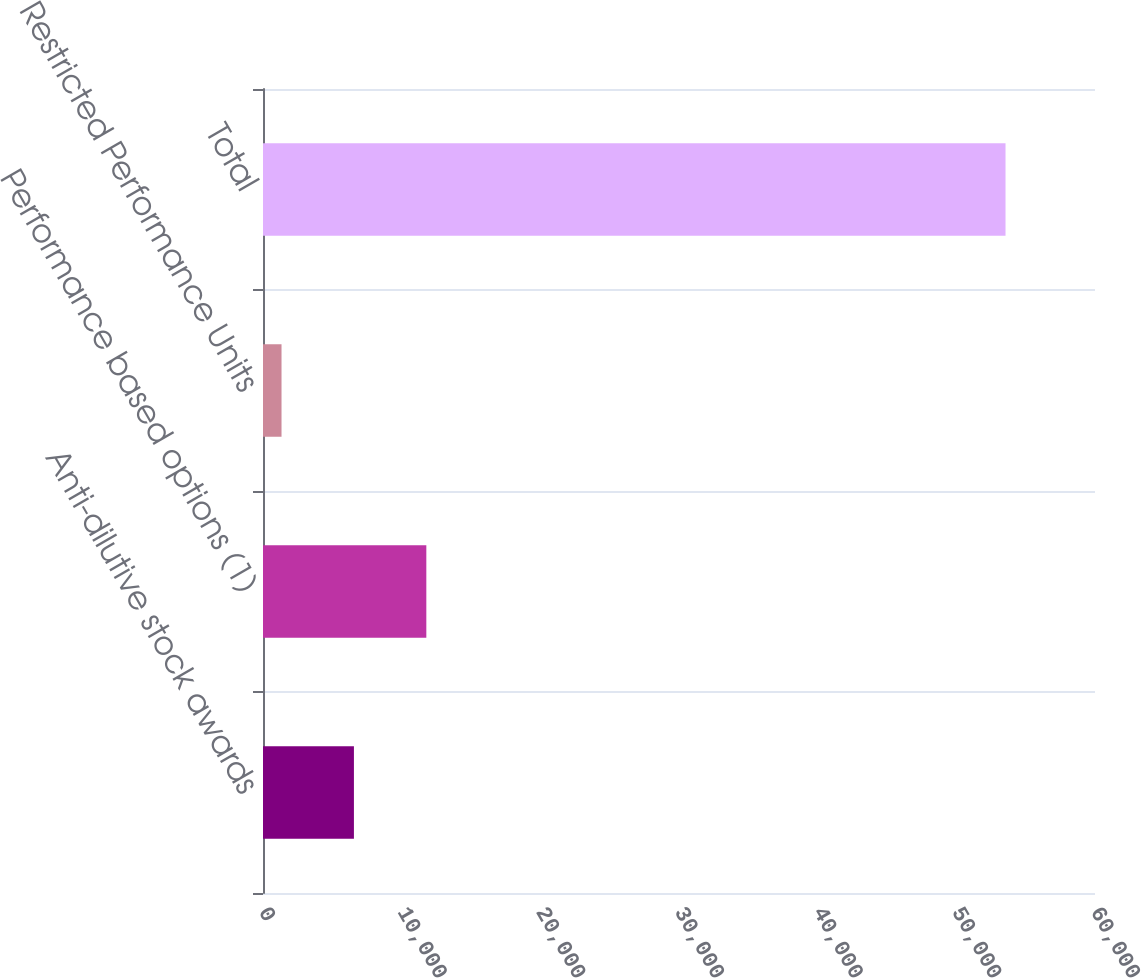<chart> <loc_0><loc_0><loc_500><loc_500><bar_chart><fcel>Anti-dilutive stock awards<fcel>Performance based options (1)<fcel>Restricted Performance Units<fcel>Total<nl><fcel>6557.1<fcel>11778.2<fcel>1336<fcel>53547<nl></chart> 